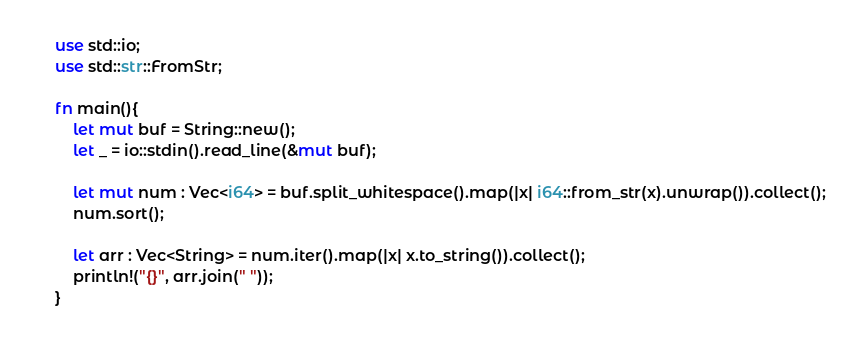Convert code to text. <code><loc_0><loc_0><loc_500><loc_500><_Rust_>use std::io;
use std::str::FromStr;

fn main(){
    let mut buf = String::new();
    let _ = io::stdin().read_line(&mut buf);

    let mut num : Vec<i64> = buf.split_whitespace().map(|x| i64::from_str(x).unwrap()).collect();
    num.sort();

    let arr : Vec<String> = num.iter().map(|x| x.to_string()).collect();
    println!("{}", arr.join(" "));
}

</code> 